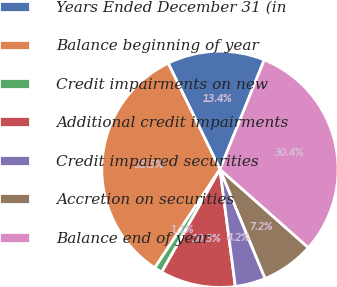Convert chart to OTSL. <chart><loc_0><loc_0><loc_500><loc_500><pie_chart><fcel>Years Ended December 31 (in<fcel>Balance beginning of year<fcel>Credit impairments on new<fcel>Additional credit impairments<fcel>Credit impaired securities<fcel>Accretion on securities<fcel>Balance end of year<nl><fcel>13.35%<fcel>33.47%<fcel>1.1%<fcel>10.29%<fcel>4.16%<fcel>7.22%<fcel>30.41%<nl></chart> 